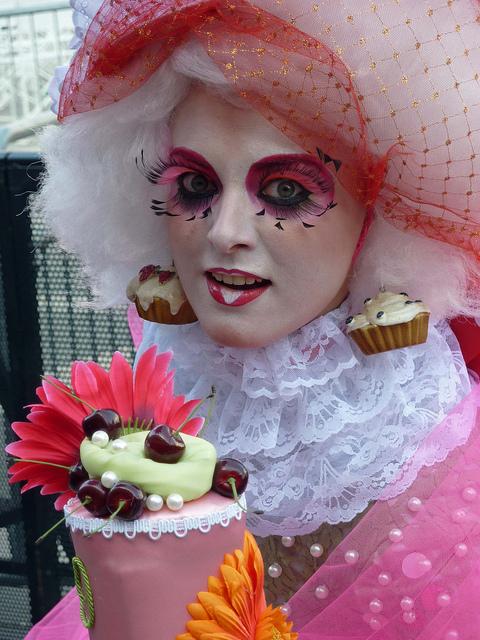What is on the ladies shoulder?
Concise answer only. Cupcakes. What color is her scarf on her head?
Be succinct. Red. What color is her hair?
Concise answer only. White. 